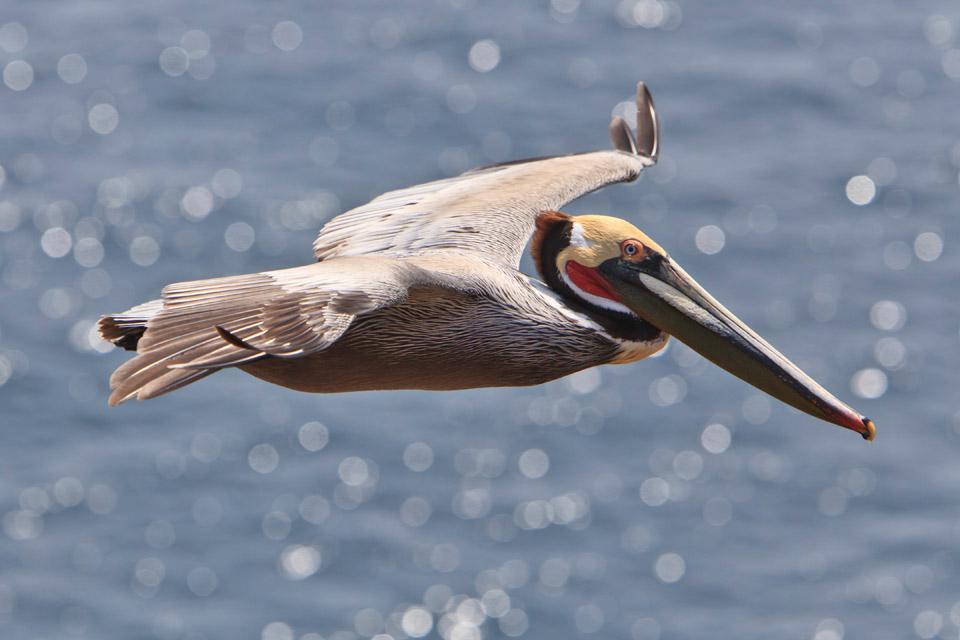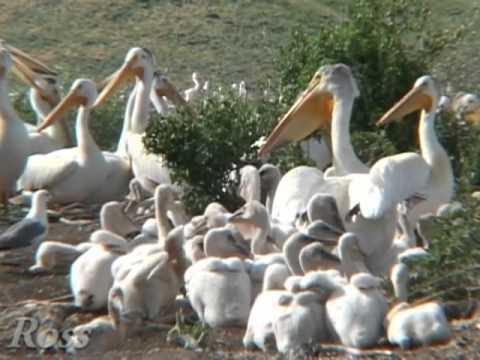The first image is the image on the left, the second image is the image on the right. Given the left and right images, does the statement "There are exactly four birds." hold true? Answer yes or no. No. The first image is the image on the left, the second image is the image on the right. Evaluate the accuracy of this statement regarding the images: "Two pelicans in one image with the same feather coloring and design are standing face to face and making contact with their heads.". Is it true? Answer yes or no. No. The first image is the image on the left, the second image is the image on the right. For the images shown, is this caption "An image shows exactly two juvenile pelicans with fuzzy white feathers posed close together." true? Answer yes or no. No. The first image is the image on the left, the second image is the image on the right. Examine the images to the left and right. Is the description "Each image shows exactly two pelicans posed close together." accurate? Answer yes or no. No. 